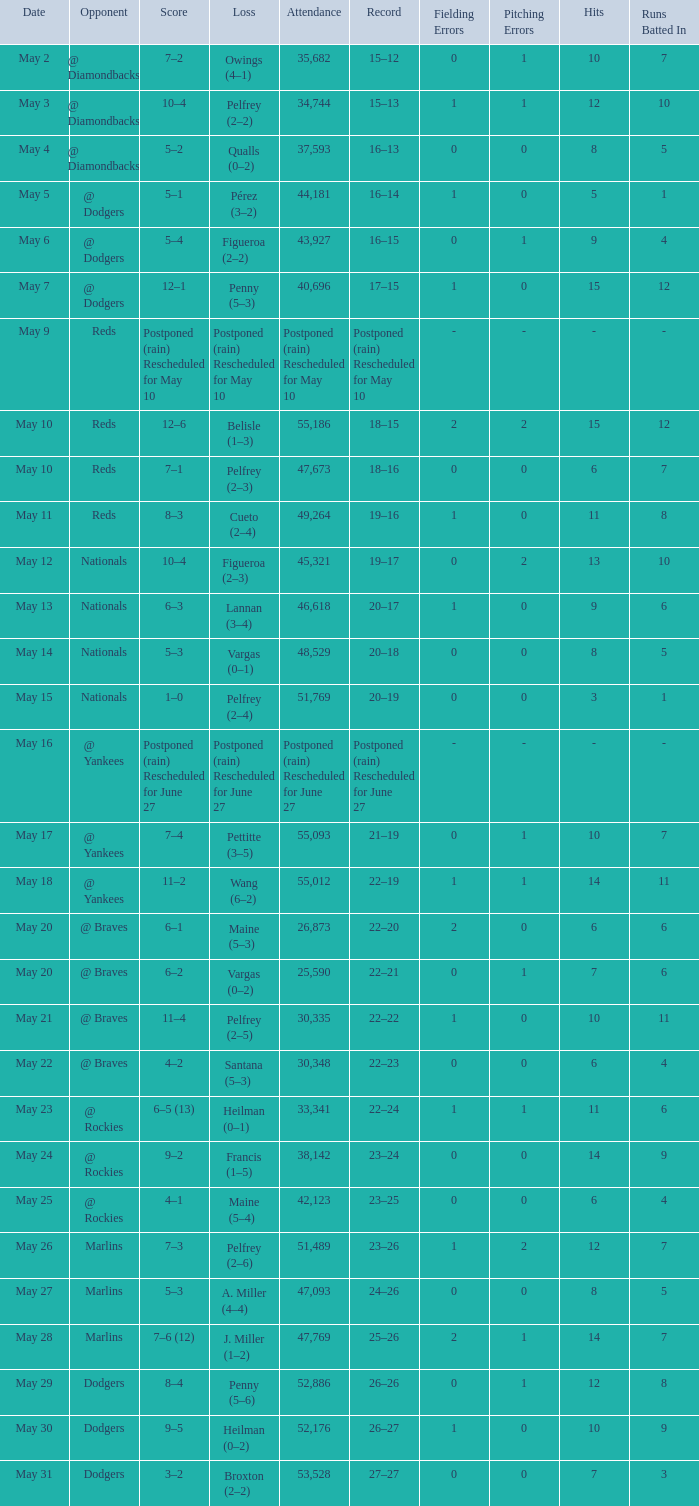Can you give me this table as a dict? {'header': ['Date', 'Opponent', 'Score', 'Loss', 'Attendance', 'Record', 'Fielding Errors', 'Pitching Errors', 'Hits', 'Runs Batted In'], 'rows': [['May 2', '@ Diamondbacks', '7–2', 'Owings (4–1)', '35,682', '15–12', '0', '1', '10', '7'], ['May 3', '@ Diamondbacks', '10–4', 'Pelfrey (2–2)', '34,744', '15–13', '1', '1', '12', '10'], ['May 4', '@ Diamondbacks', '5–2', 'Qualls (0–2)', '37,593', '16–13', '0', '0', '8', '5'], ['May 5', '@ Dodgers', '5–1', 'Pérez (3–2)', '44,181', '16–14', '1', '0', '5', '1'], ['May 6', '@ Dodgers', '5–4', 'Figueroa (2–2)', '43,927', '16–15', '0', '1', '9', '4'], ['May 7', '@ Dodgers', '12–1', 'Penny (5–3)', '40,696', '17–15', '1', '0', '15', '12'], ['May 9', 'Reds', 'Postponed (rain) Rescheduled for May 10', 'Postponed (rain) Rescheduled for May 10', 'Postponed (rain) Rescheduled for May 10', 'Postponed (rain) Rescheduled for May 10', '-', '-', '-', '-'], ['May 10', 'Reds', '12–6', 'Belisle (1–3)', '55,186', '18–15', '2', '2', '15', '12'], ['May 10', 'Reds', '7–1', 'Pelfrey (2–3)', '47,673', '18–16', '0', '0', '6', '7'], ['May 11', 'Reds', '8–3', 'Cueto (2–4)', '49,264', '19–16', '1', '0', '11', '8'], ['May 12', 'Nationals', '10–4', 'Figueroa (2–3)', '45,321', '19–17', '0', '2', '13', '10'], ['May 13', 'Nationals', '6–3', 'Lannan (3–4)', '46,618', '20–17', '1', '0', '9', '6'], ['May 14', 'Nationals', '5–3', 'Vargas (0–1)', '48,529', '20–18', '0', '0', '8', '5'], ['May 15', 'Nationals', '1–0', 'Pelfrey (2–4)', '51,769', '20–19', '0', '0', '3', '1'], ['May 16', '@ Yankees', 'Postponed (rain) Rescheduled for June 27', 'Postponed (rain) Rescheduled for June 27', 'Postponed (rain) Rescheduled for June 27', 'Postponed (rain) Rescheduled for June 27', '-', '-', '-', '-'], ['May 17', '@ Yankees', '7–4', 'Pettitte (3–5)', '55,093', '21–19', '0', '1', '10', '7'], ['May 18', '@ Yankees', '11–2', 'Wang (6–2)', '55,012', '22–19', '1', '1', '14', '11'], ['May 20', '@ Braves', '6–1', 'Maine (5–3)', '26,873', '22–20', '2', '0', '6', '6'], ['May 20', '@ Braves', '6–2', 'Vargas (0–2)', '25,590', '22–21', '0', '1', '7', '6'], ['May 21', '@ Braves', '11–4', 'Pelfrey (2–5)', '30,335', '22–22', '1', '0', '10', '11'], ['May 22', '@ Braves', '4–2', 'Santana (5–3)', '30,348', '22–23', '0', '0', '6', '4'], ['May 23', '@ Rockies', '6–5 (13)', 'Heilman (0–1)', '33,341', '22–24', '1', '1', '11', '6'], ['May 24', '@ Rockies', '9–2', 'Francis (1–5)', '38,142', '23–24', '0', '0', '14', '9'], ['May 25', '@ Rockies', '4–1', 'Maine (5–4)', '42,123', '23–25', '0', '0', '6', '4'], ['May 26', 'Marlins', '7–3', 'Pelfrey (2–6)', '51,489', '23–26', '1', '2', '12', '7'], ['May 27', 'Marlins', '5–3', 'A. Miller (4–4)', '47,093', '24–26', '0', '0', '8', '5'], ['May 28', 'Marlins', '7–6 (12)', 'J. Miller (1–2)', '47,769', '25–26', '2', '1', '14', '7'], ['May 29', 'Dodgers', '8–4', 'Penny (5–6)', '52,886', '26–26', '0', '1', '12', '8'], ['May 30', 'Dodgers', '9–5', 'Heilman (0–2)', '52,176', '26–27', '1', '0', '10', '9'], ['May 31', 'Dodgers', '3–2', 'Broxton (2–2)', '53,528', '27–27', '0', '0', '7', '3']]} Attendance of 30,335 had what record? 22–22. 